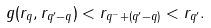<formula> <loc_0><loc_0><loc_500><loc_500>g ( r _ { q } , r _ { q ^ { \prime } - q } ) < r _ { q ^ { - } + ( q ^ { \prime } - q ) } < r _ { q ^ { \prime } } .</formula> 